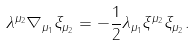<formula> <loc_0><loc_0><loc_500><loc_500>\lambda ^ { \mu _ { 2 } } \nabla _ { \mu _ { 1 } } \xi _ { \mu _ { 2 } } = - \frac { 1 } { 2 } \lambda _ { \mu _ { 1 } } \xi ^ { \mu _ { 2 } } \xi _ { \mu _ { 2 } } .</formula> 